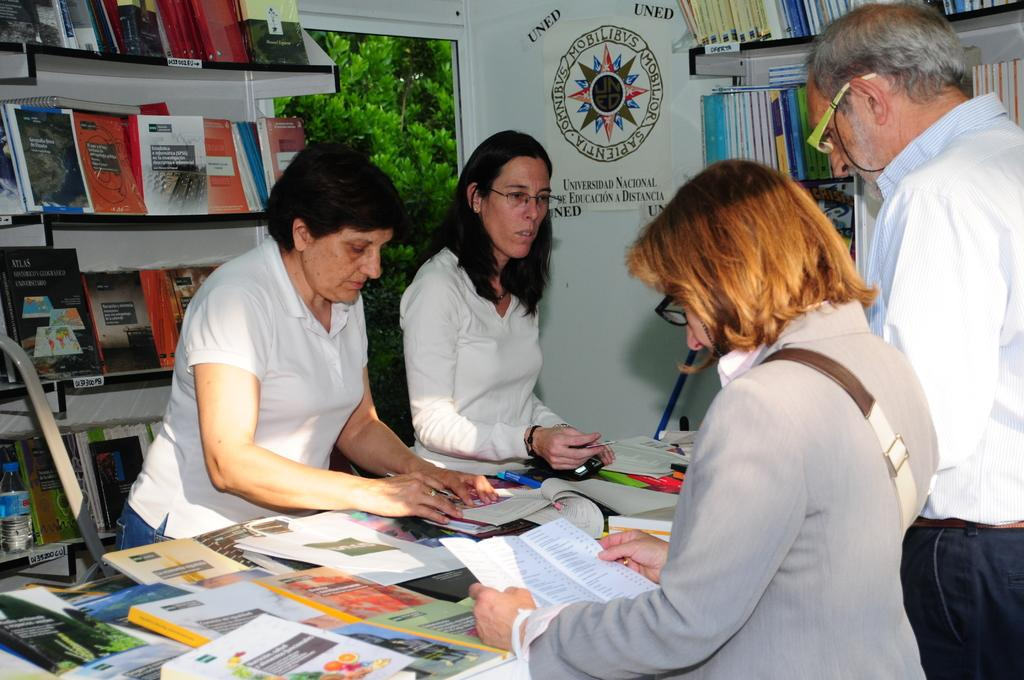Provide a one-sentence caption for the provided image. Four people are standing in front of a sign for the Universidad National De Educacion A Distancia. 